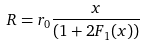<formula> <loc_0><loc_0><loc_500><loc_500>R = r _ { 0 } \frac { x } { ( 1 + 2 F _ { 1 } ( x ) ) }</formula> 